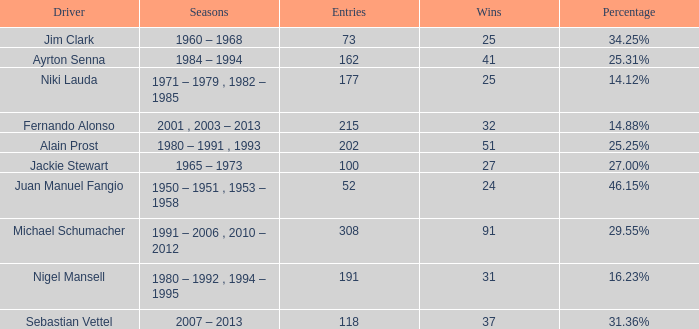Which driver has 162 entries? Ayrton Senna. 